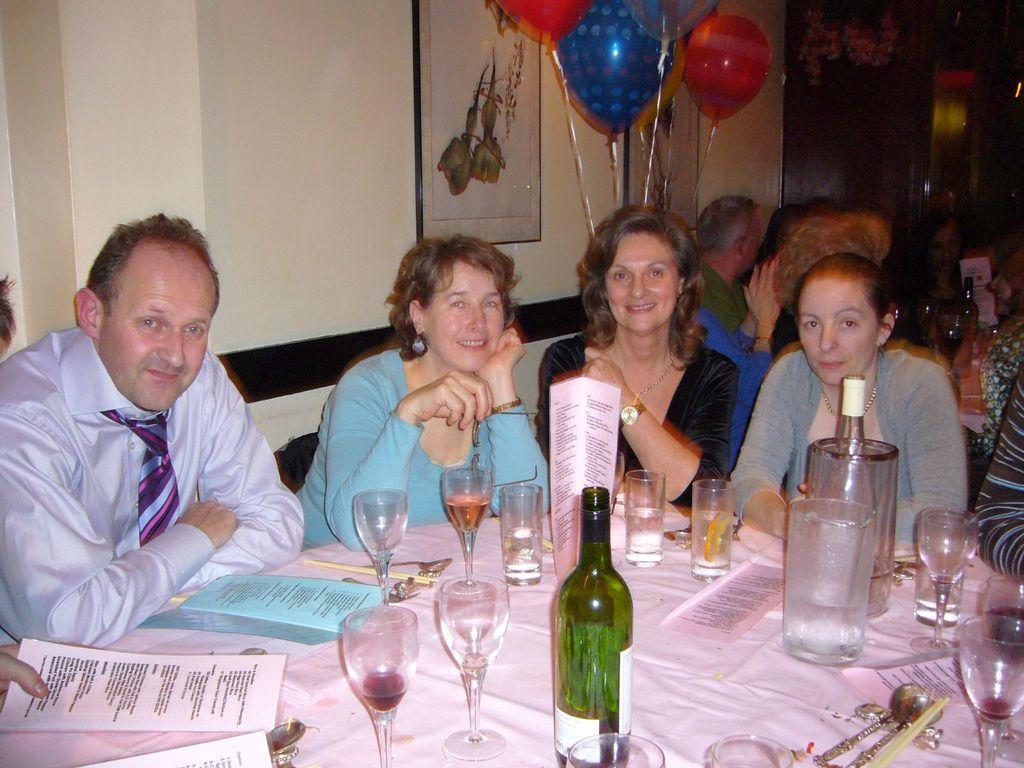Describe this image in one or two sentences. In this image, a group of people sitting on the chair in front of the table on which glass, beverage bottle, menu cards etc., kept. Background wall is white in color. In the middle right balloons are there and a wall painting is there on the wall. This image is taken inside the restaurant. 